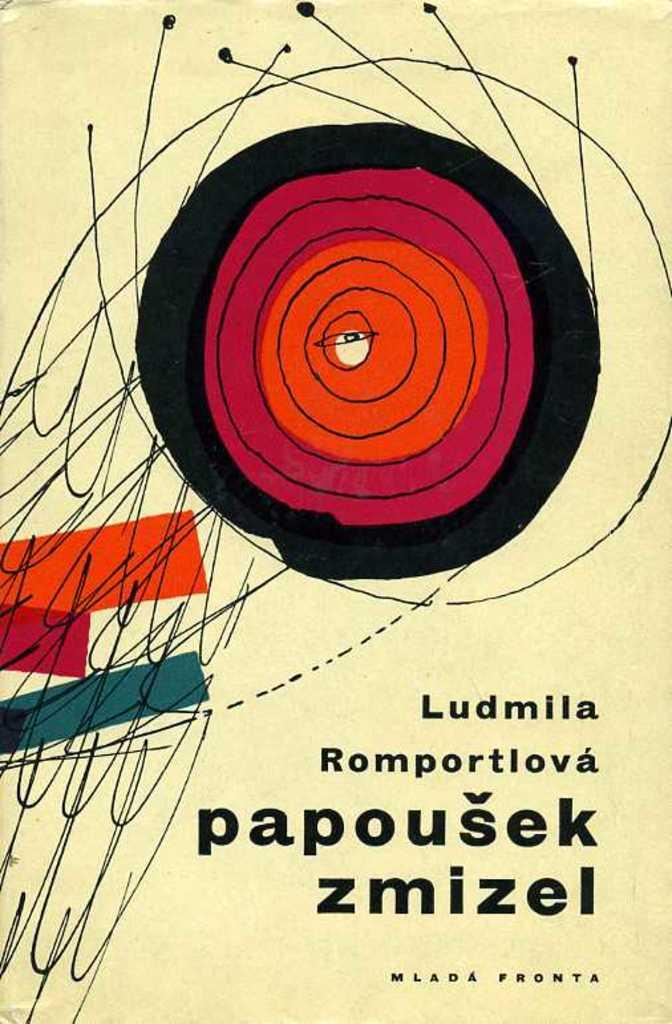Provide a one-sentence caption for the provided image. A book that is titled Papousek zmizel in another language. 